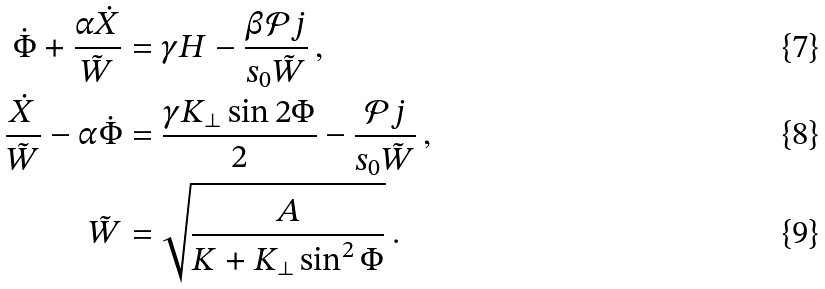Convert formula to latex. <formula><loc_0><loc_0><loc_500><loc_500>\dot { \Phi } + \frac { \alpha \dot { X } } { \tilde { W } } & = \gamma H - \frac { \beta \mathcal { P } j } { s _ { 0 } \tilde { W } } \, , \\ \frac { \dot { X } } { \tilde { W } } - \alpha \dot { \Phi } & = \frac { \gamma K _ { \perp } \sin 2 \Phi } { 2 } - \frac { \mathcal { P } j } { s _ { 0 } \tilde { W } } \, , \\ \tilde { W } & = \sqrt { \frac { A } { K + K _ { \perp } \sin ^ { 2 } \Phi } } \, .</formula> 